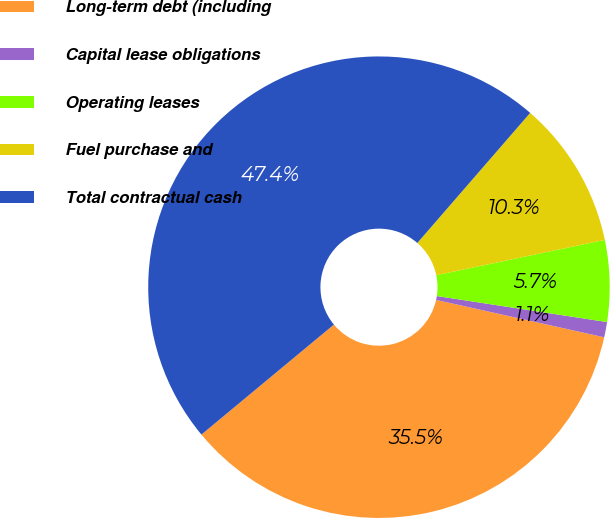Convert chart to OTSL. <chart><loc_0><loc_0><loc_500><loc_500><pie_chart><fcel>Long-term debt (including<fcel>Capital lease obligations<fcel>Operating leases<fcel>Fuel purchase and<fcel>Total contractual cash<nl><fcel>35.49%<fcel>1.07%<fcel>5.7%<fcel>10.34%<fcel>47.4%<nl></chart> 